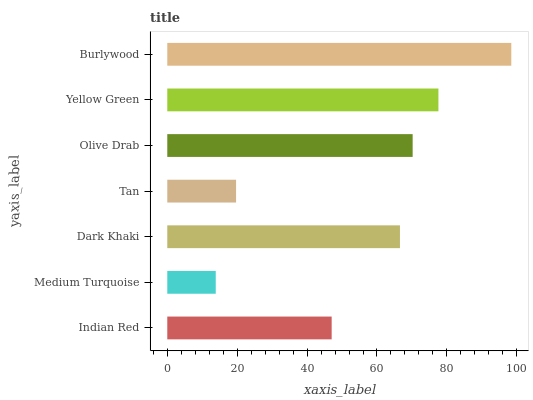Is Medium Turquoise the minimum?
Answer yes or no. Yes. Is Burlywood the maximum?
Answer yes or no. Yes. Is Dark Khaki the minimum?
Answer yes or no. No. Is Dark Khaki the maximum?
Answer yes or no. No. Is Dark Khaki greater than Medium Turquoise?
Answer yes or no. Yes. Is Medium Turquoise less than Dark Khaki?
Answer yes or no. Yes. Is Medium Turquoise greater than Dark Khaki?
Answer yes or no. No. Is Dark Khaki less than Medium Turquoise?
Answer yes or no. No. Is Dark Khaki the high median?
Answer yes or no. Yes. Is Dark Khaki the low median?
Answer yes or no. Yes. Is Yellow Green the high median?
Answer yes or no. No. Is Burlywood the low median?
Answer yes or no. No. 